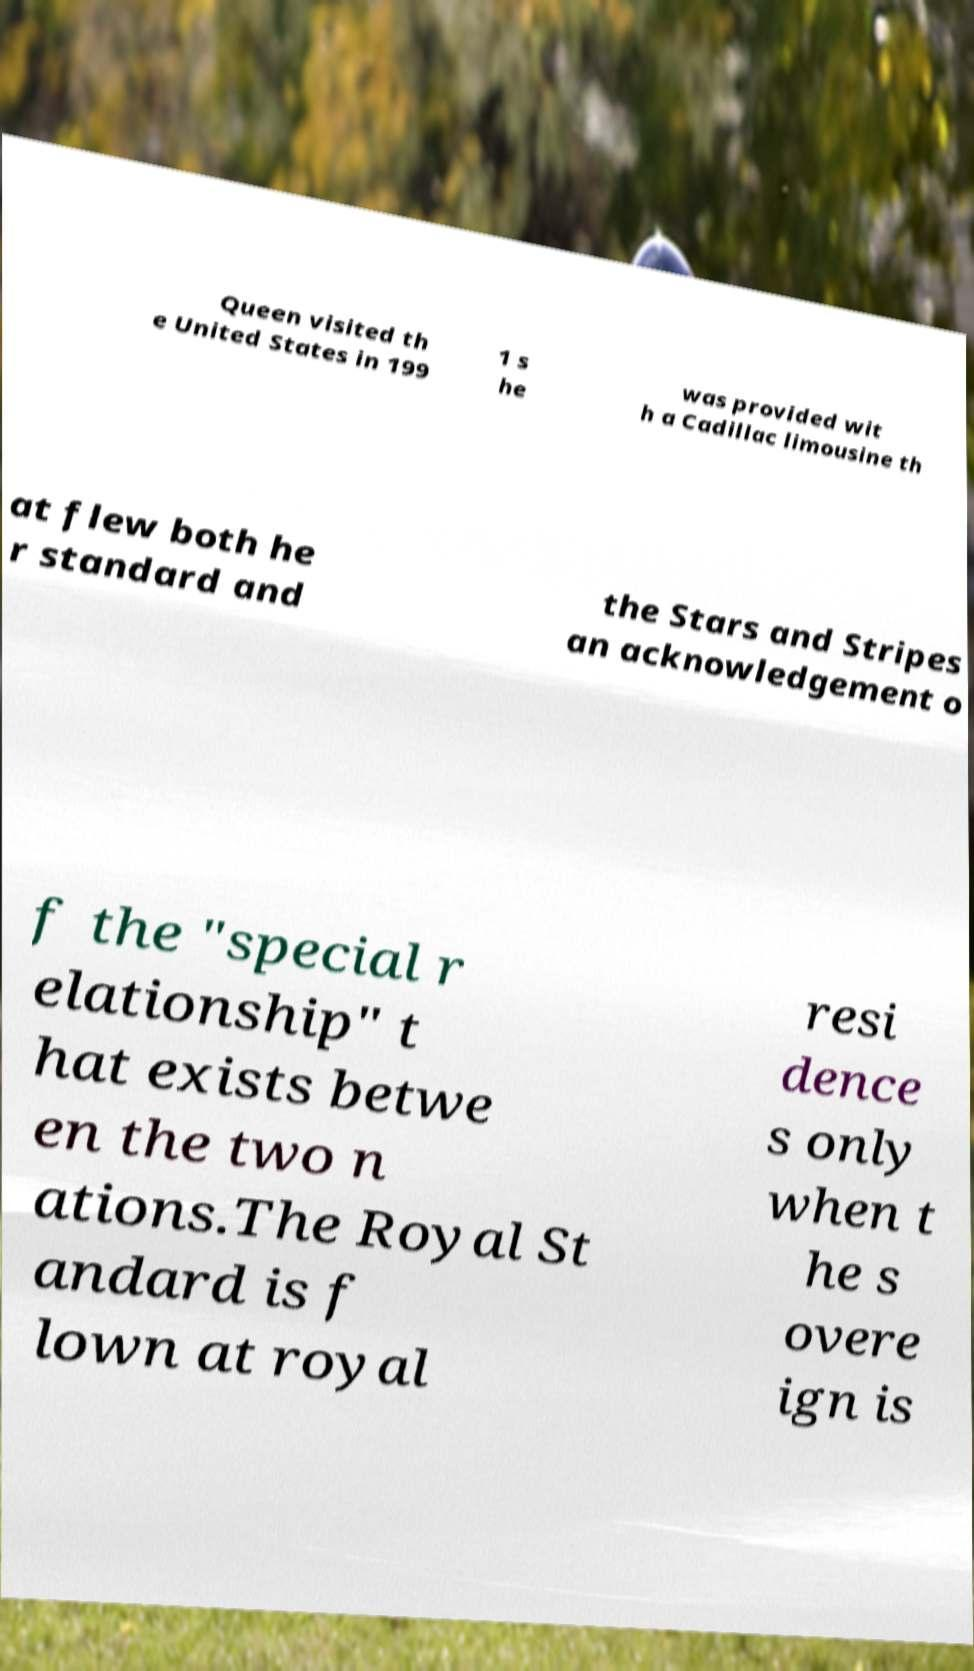There's text embedded in this image that I need extracted. Can you transcribe it verbatim? Queen visited th e United States in 199 1 s he was provided wit h a Cadillac limousine th at flew both he r standard and the Stars and Stripes an acknowledgement o f the "special r elationship" t hat exists betwe en the two n ations.The Royal St andard is f lown at royal resi dence s only when t he s overe ign is 